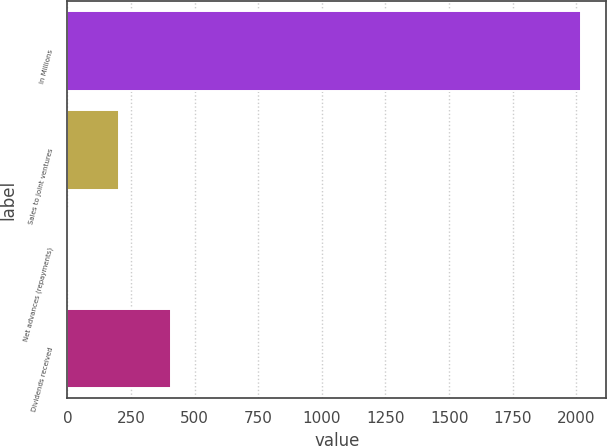Convert chart to OTSL. <chart><loc_0><loc_0><loc_500><loc_500><bar_chart><fcel>In Millions<fcel>Sales to joint ventures<fcel>Net advances (repayments)<fcel>Dividends received<nl><fcel>2017<fcel>204.67<fcel>3.3<fcel>406.04<nl></chart> 